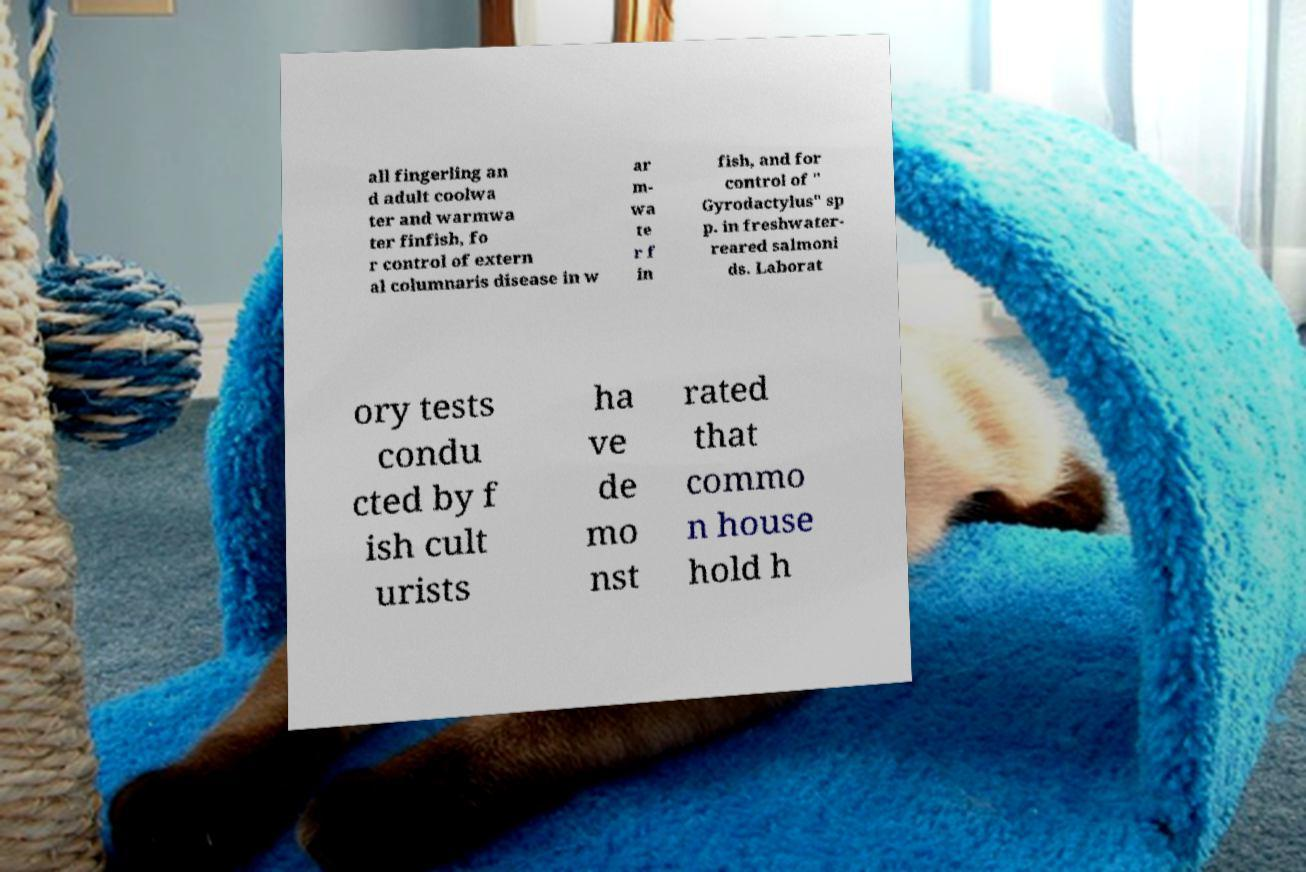Please read and relay the text visible in this image. What does it say? all fingerling an d adult coolwa ter and warmwa ter finfish, fo r control of extern al columnaris disease in w ar m- wa te r f in fish, and for control of " Gyrodactylus" sp p. in freshwater- reared salmoni ds. Laborat ory tests condu cted by f ish cult urists ha ve de mo nst rated that commo n house hold h 